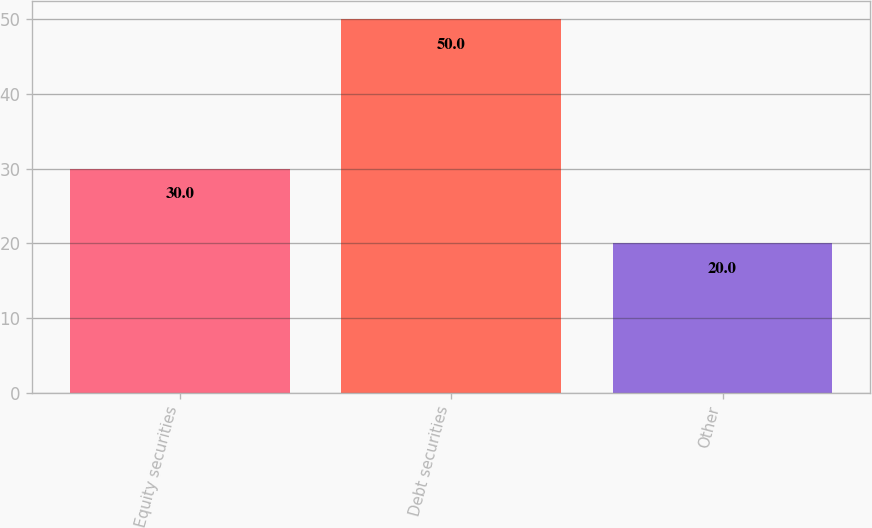<chart> <loc_0><loc_0><loc_500><loc_500><bar_chart><fcel>Equity securities<fcel>Debt securities<fcel>Other<nl><fcel>30<fcel>50<fcel>20<nl></chart> 